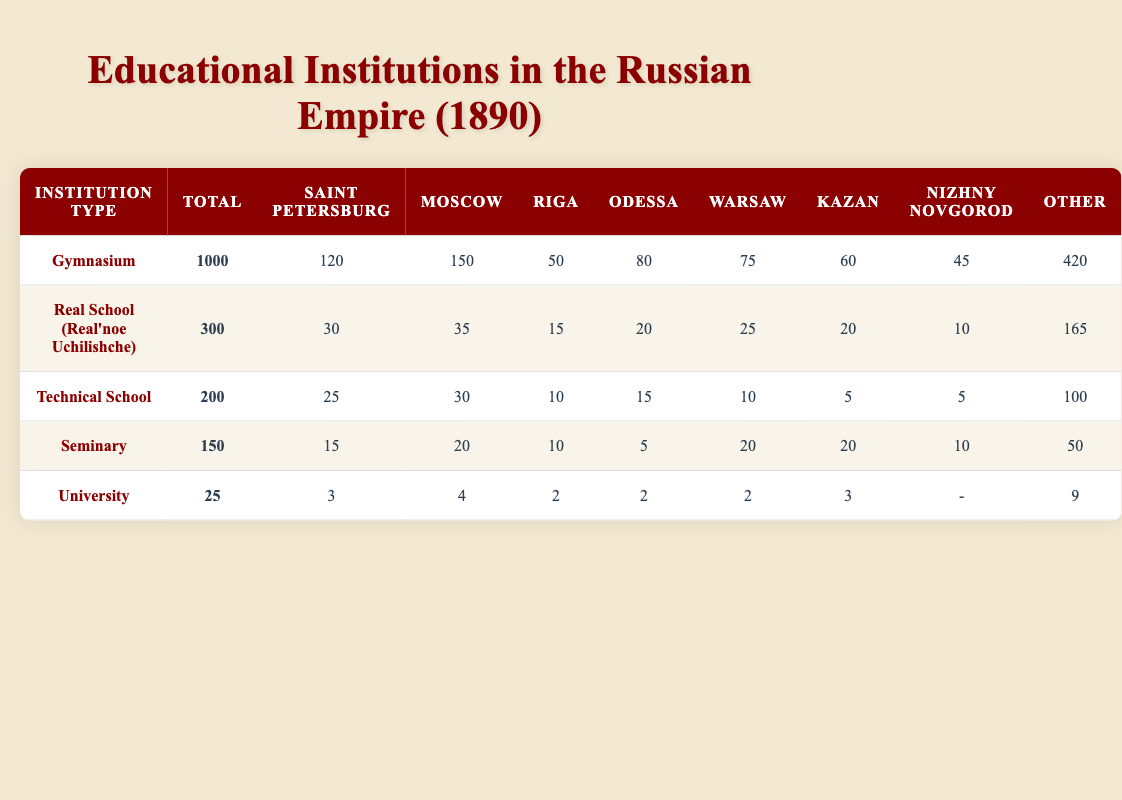What is the total number of Gymnasiums in the Russian Empire as of 1890? The table explicitly states the total number of Gymnasiums in the Russian Empire as 1000.
Answer: 1000 How many Real Schools are located in Nizhny Novgorod? According to the table, the number of Real Schools in Nizhny Novgorod is 10.
Answer: 10 Which city has the highest number of Technical Schools? The table shows that Moscow has 30 Technical Schools, which is the highest among all listed cities.
Answer: Moscow What is the total number of Universities across all cities? The total number of Universities is calculated by simply referring to the "Total" column, which shows that there are 25 Universities in total.
Answer: 25 Is it true that there are more Gymnasiums than the combined total of Technical Schools and Seminaries? To check this, first, sum the total number of Technical Schools (200) and Seminaries (150), which equals 350. Since the total number of Gymnasiums is 1000, it is indeed greater than 350.
Answer: Yes What is the average number of Gymnasiums per major city (counting only Saint Petersburg, Moscow, and Odessa)? Calculate the total number of Gymnasiums in these cities: 120 (Saint Petersburg) + 150 (Moscow) + 80 (Odessa) = 350. Then, divide by the number of cities: 350 / 3 = 116.67.
Answer: 116.67 Which city has the least number of Seminaries, and how many do they have? The table shows that Odessa has the least number of Seminaries, which is 5.
Answer: Odessa, 5 If a new Gymnasium opens in Nizhny Novgorod, what would be the new total for Gymnasiums in the Russian Empire? The current total of Gymnasiums is 1000. Adding 1 for the new Gymnasium would give 1000 + 1 = 1001.
Answer: 1001 What is the total number of educational institutions listed in the table? To find the total, sum the "Total" column: 1000 (Gymnasium) + 300 (Real School) + 200 (Technical School) + 150 (Seminary) + 25 (University) = 1675.
Answer: 1675 